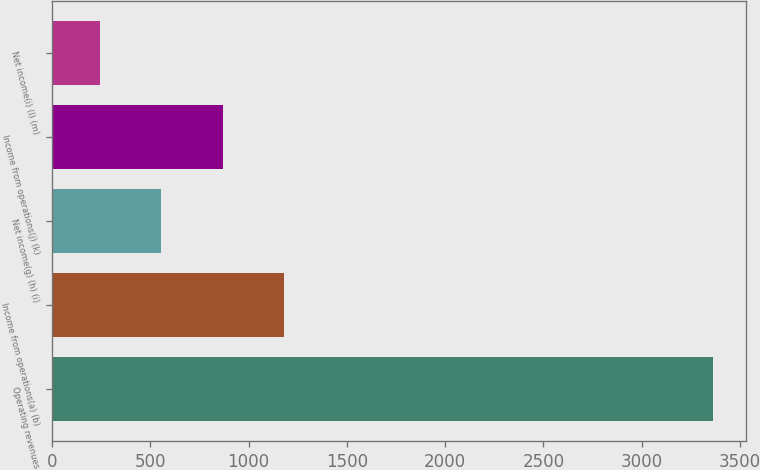Convert chart. <chart><loc_0><loc_0><loc_500><loc_500><bar_chart><fcel>Operating revenues<fcel>Income from operations(a) (b)<fcel>Net income(g) (h) (i)<fcel>Income from operations(j) (k)<fcel>Net income(i) (l) (m)<nl><fcel>3361<fcel>1180.5<fcel>557.5<fcel>869<fcel>246<nl></chart> 